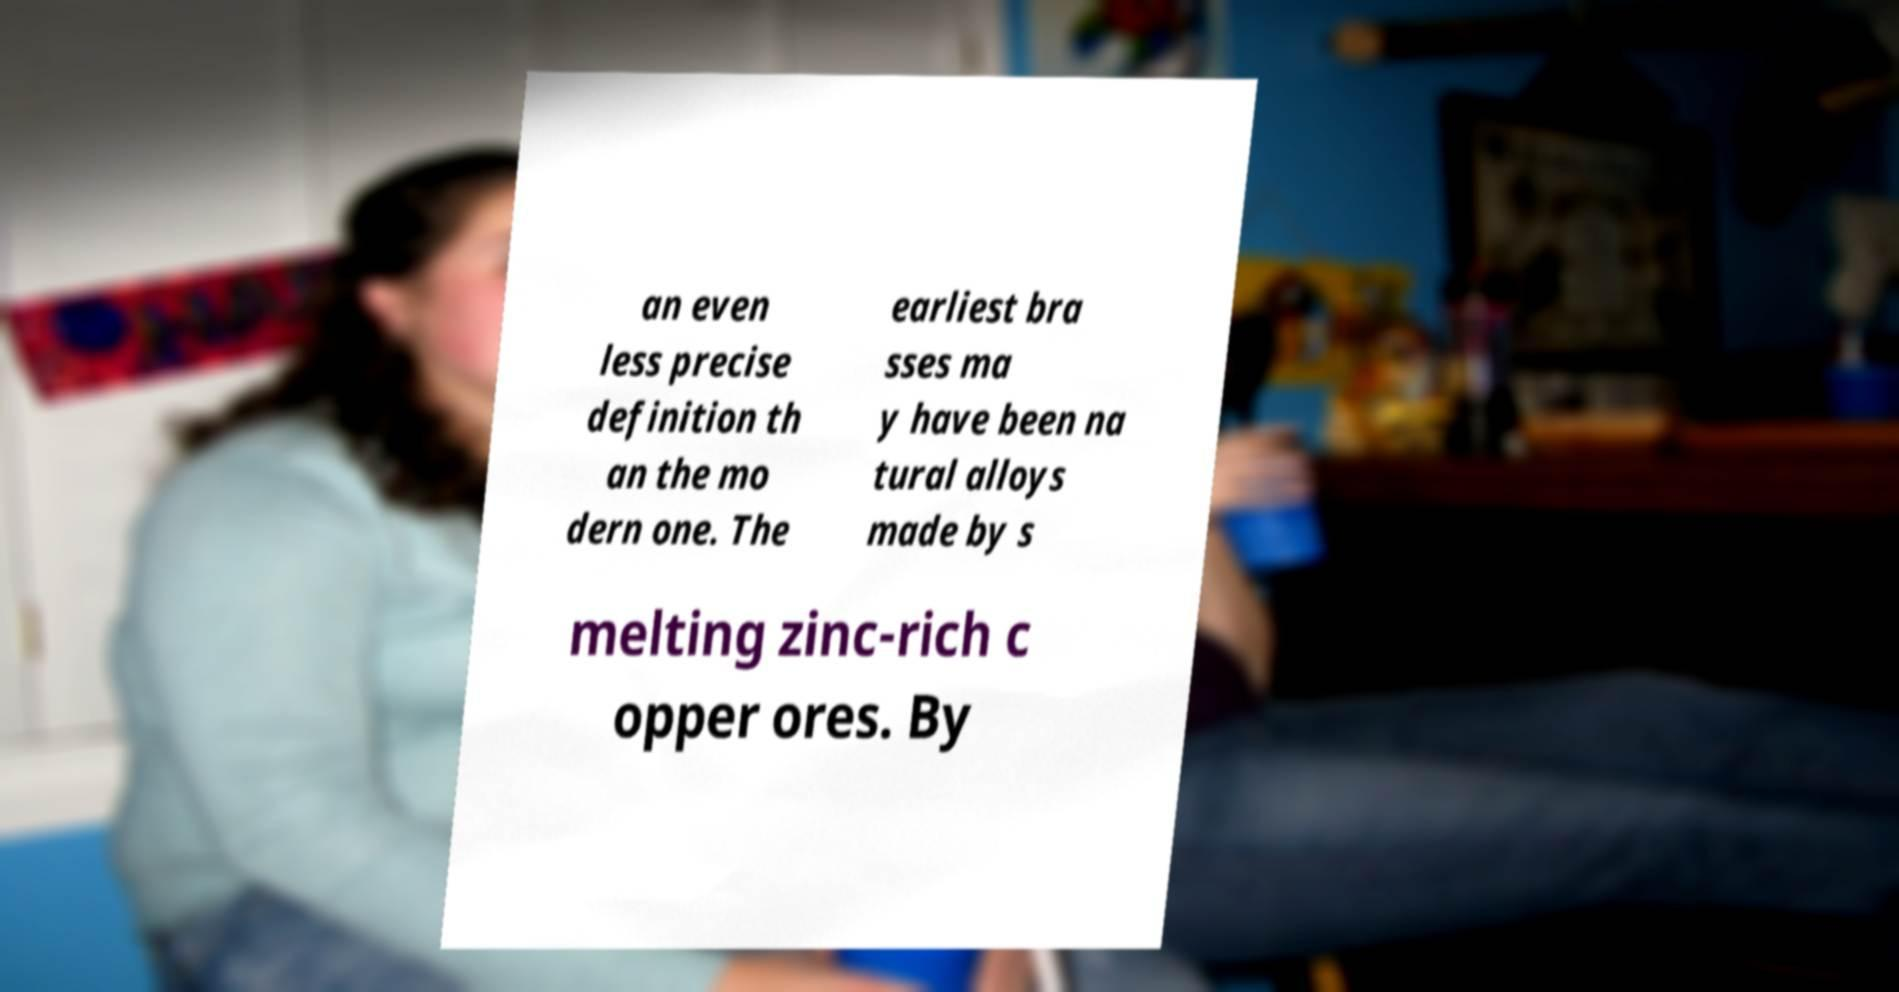There's text embedded in this image that I need extracted. Can you transcribe it verbatim? an even less precise definition th an the mo dern one. The earliest bra sses ma y have been na tural alloys made by s melting zinc-rich c opper ores. By 